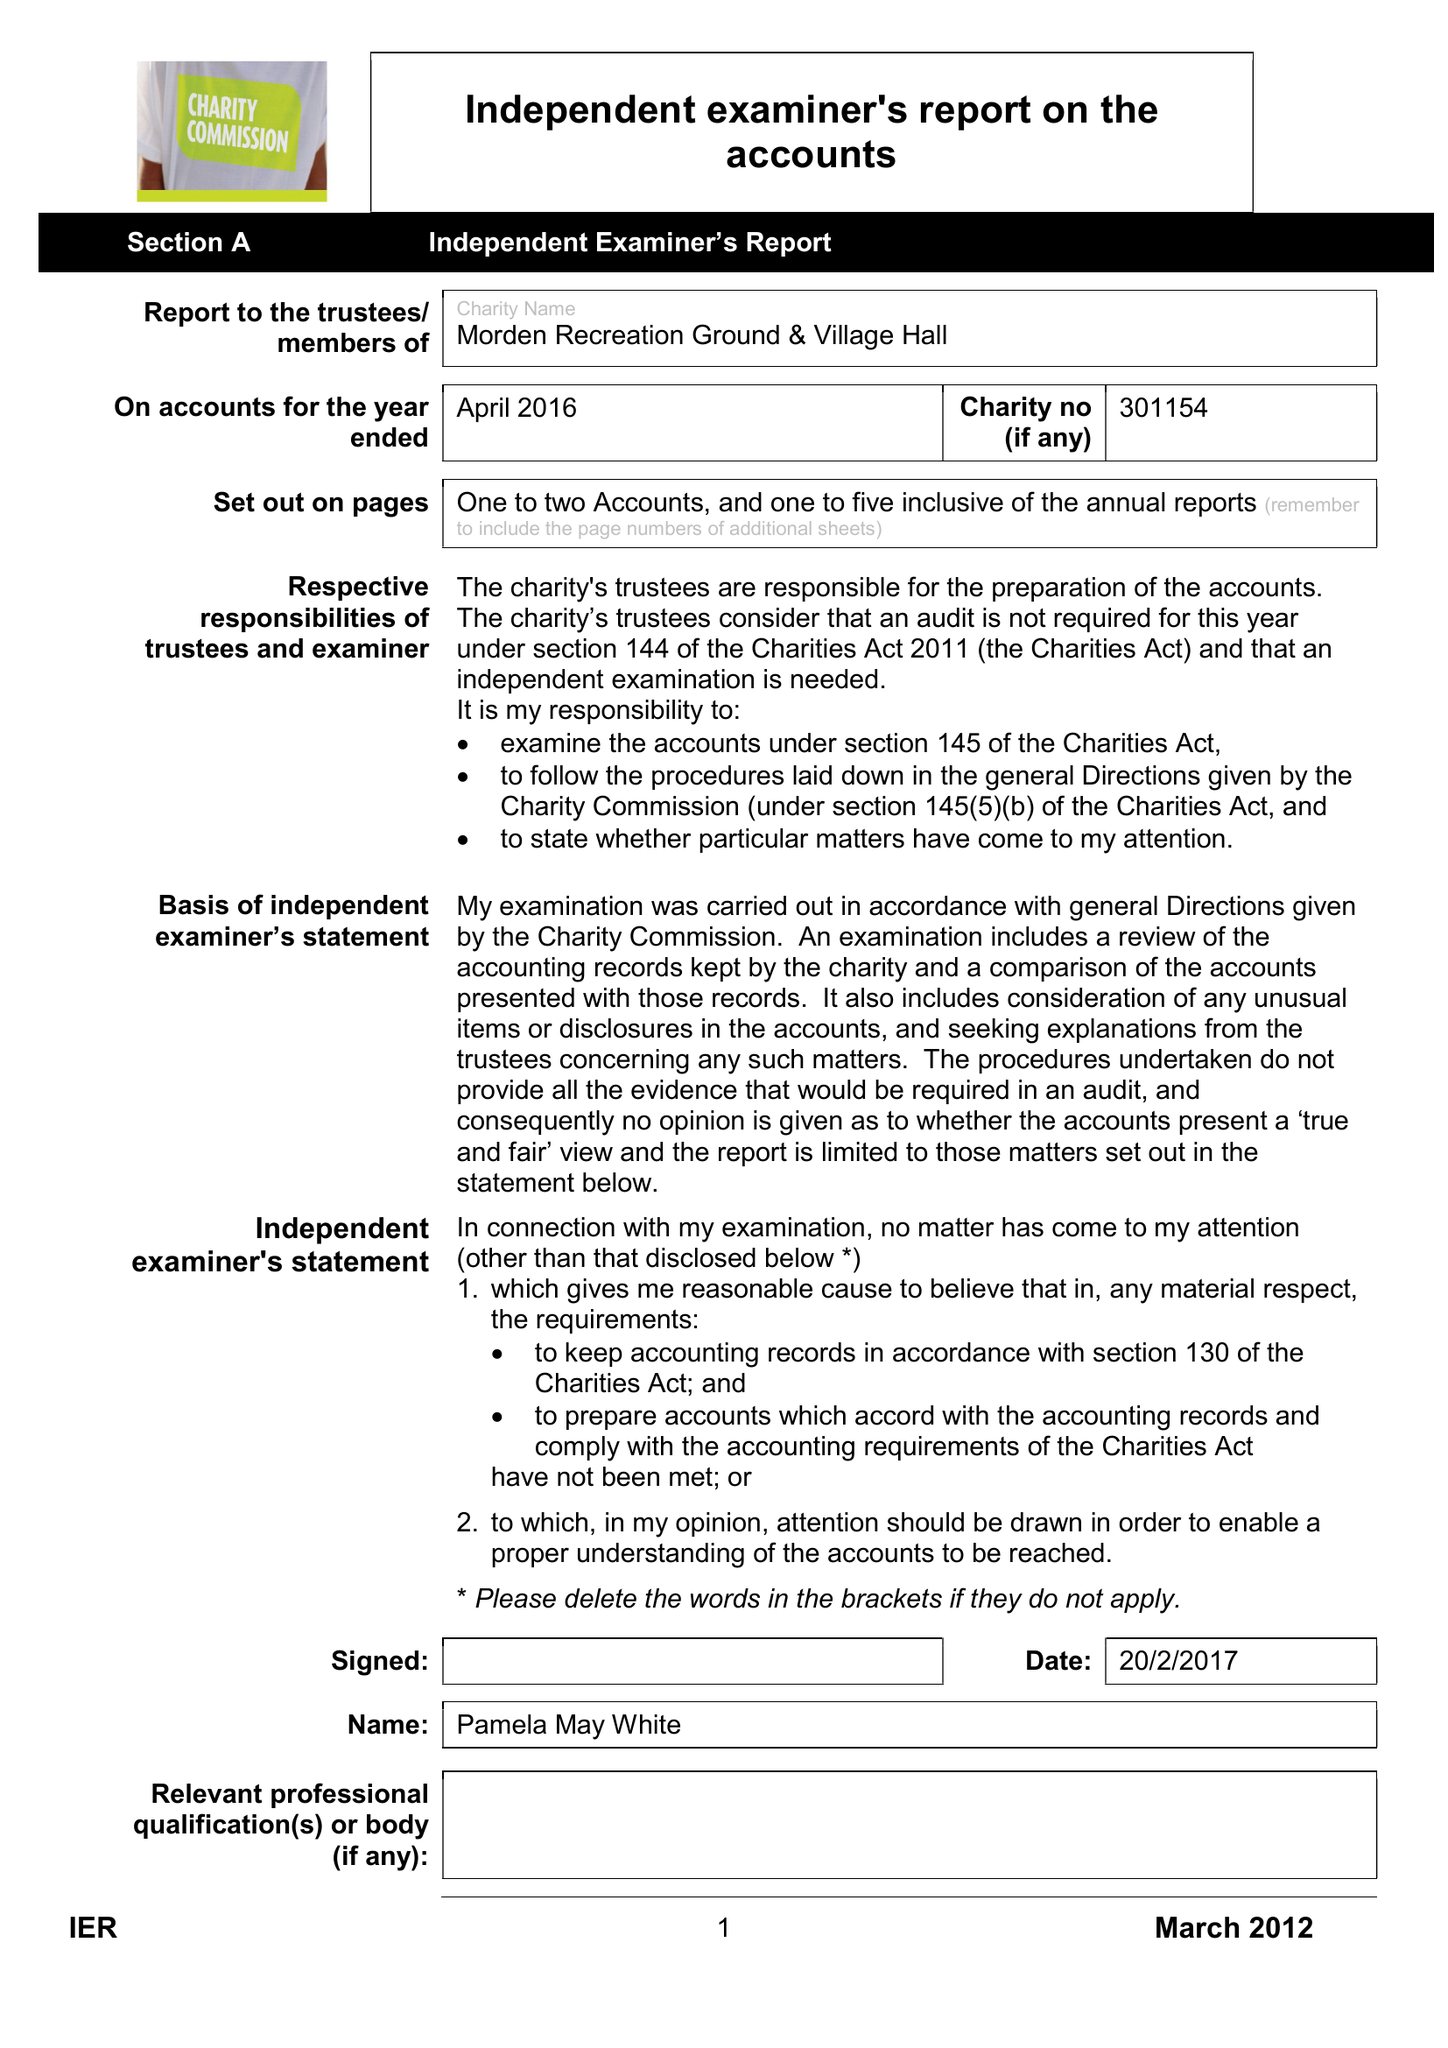What is the value for the spending_annually_in_british_pounds?
Answer the question using a single word or phrase. 14001.00 